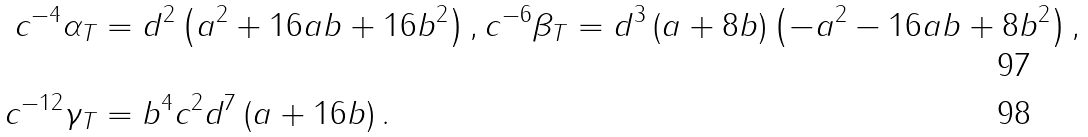Convert formula to latex. <formula><loc_0><loc_0><loc_500><loc_500>c ^ { - 4 } \alpha _ { T } & = d ^ { 2 } \left ( a ^ { 2 } + 1 6 a b + 1 6 b ^ { 2 } \right ) , c ^ { - 6 } \beta _ { T } = d ^ { 3 } \left ( a + 8 b \right ) \left ( - a ^ { 2 } - 1 6 a b + 8 b ^ { 2 } \right ) , \\ c ^ { - 1 2 } \gamma _ { T } & = b ^ { 4 } c ^ { 2 } d ^ { 7 } \left ( a + 1 6 b \right ) .</formula> 